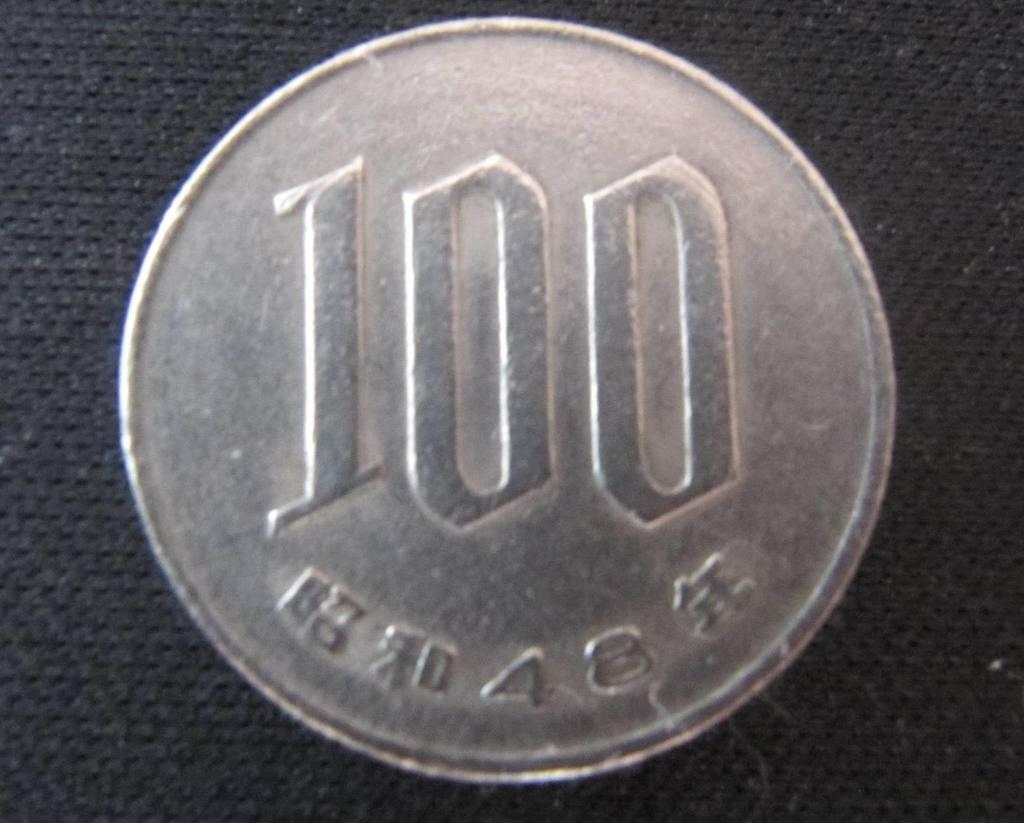<image>
Summarize the visual content of the image. Silver coin with chinese words wrote on it and one hundred 